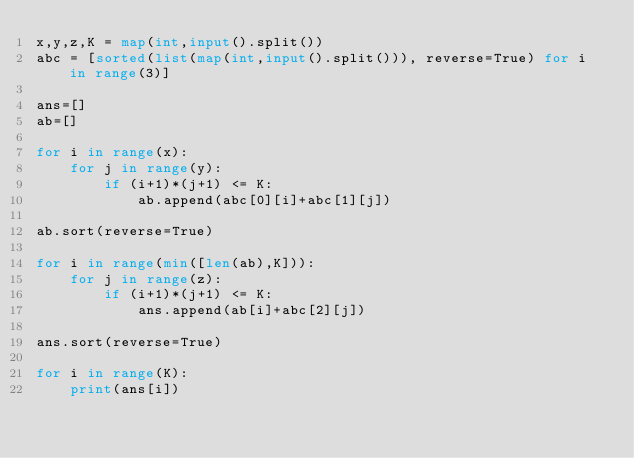Convert code to text. <code><loc_0><loc_0><loc_500><loc_500><_Python_>x,y,z,K = map(int,input().split())
abc = [sorted(list(map(int,input().split())), reverse=True) for i in range(3)]

ans=[]
ab=[]

for i in range(x):
    for j in range(y):
        if (i+1)*(j+1) <= K:
            ab.append(abc[0][i]+abc[1][j])

ab.sort(reverse=True)

for i in range(min([len(ab),K])):
    for j in range(z):
        if (i+1)*(j+1) <= K:
            ans.append(ab[i]+abc[2][j])
    
ans.sort(reverse=True)

for i in range(K):
    print(ans[i])</code> 